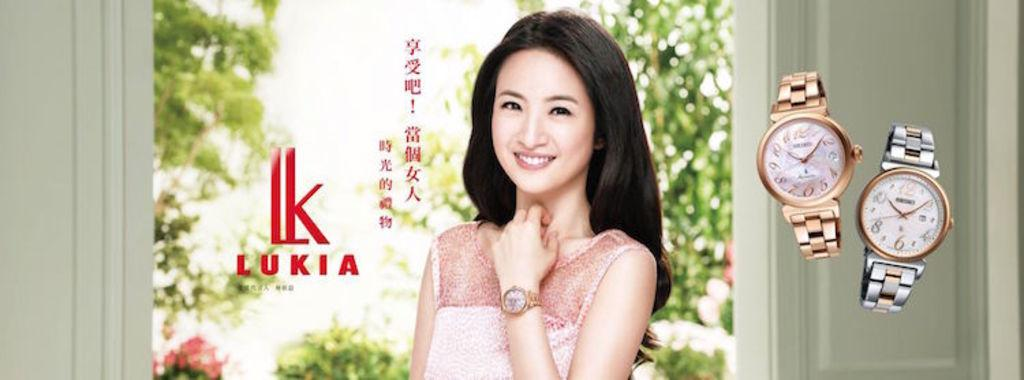<image>
Create a compact narrative representing the image presented. Ad showing a woman and the word LUKIA next to her. 